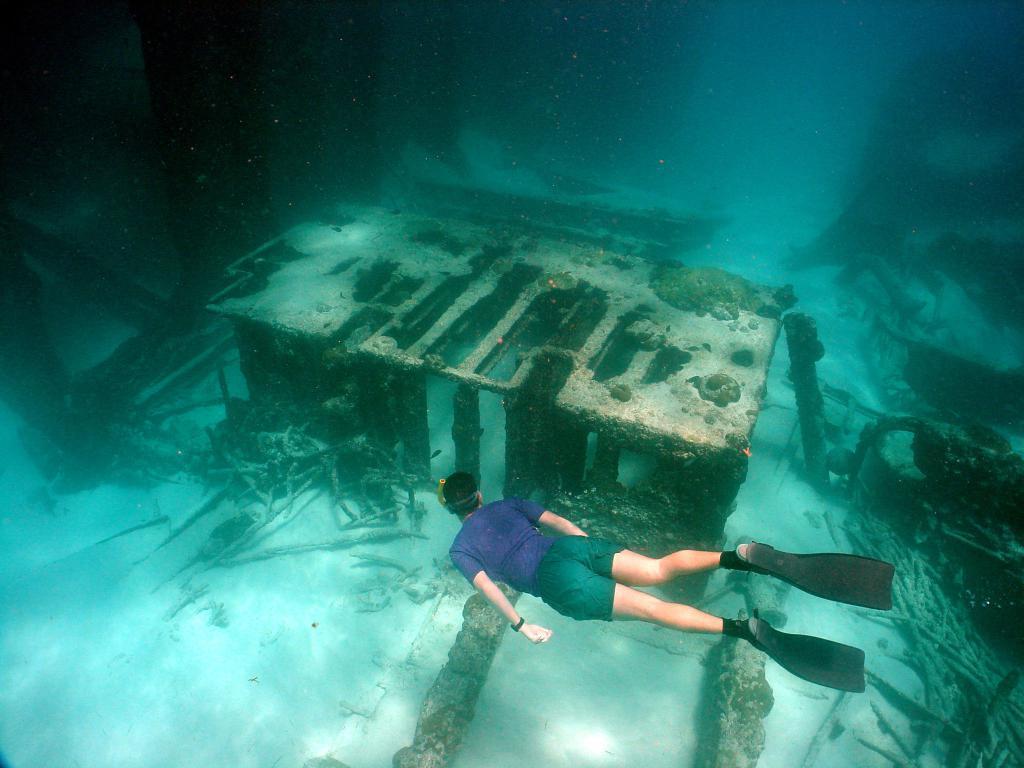Could you give a brief overview of what you see in this image? At the bottom of the image we can see a man is swimming in the water and wearing dress, watch, swimming foot paddles. In the background of the image we can see the twigs, bricks, sand and shed. 